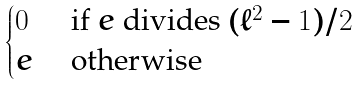Convert formula to latex. <formula><loc_0><loc_0><loc_500><loc_500>\begin{cases} 0 & \text { if } e \text { divides } ( \ell ^ { 2 } - 1 ) / 2 \\ e & \text { otherwise } \end{cases}</formula> 